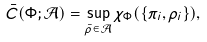<formula> <loc_0><loc_0><loc_500><loc_500>\bar { C } ( \Phi ; \mathcal { A } ) = \sup _ { \bar { \rho } \in \mathcal { A } } \chi _ { \Phi } ( \{ \pi _ { i } , \rho _ { i } \} ) ,</formula> 